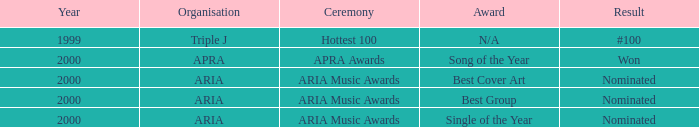What's the reward for #100? N/A. 